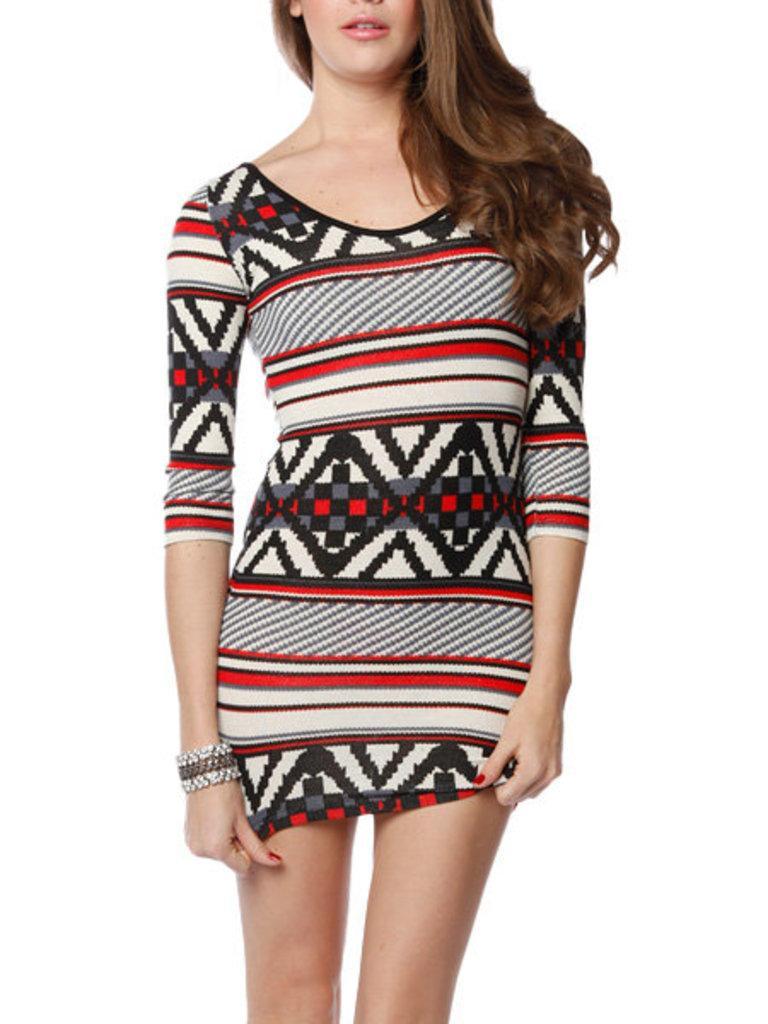In one or two sentences, can you explain what this image depicts? In this image I can see a girl standing. 